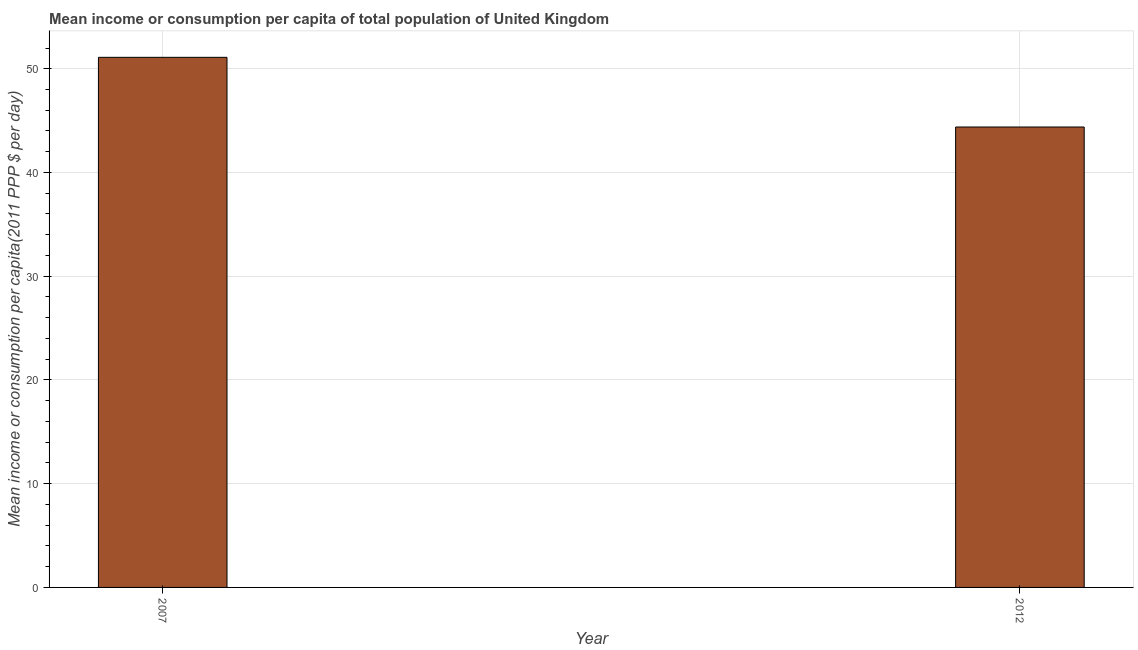Does the graph contain grids?
Provide a short and direct response. Yes. What is the title of the graph?
Offer a very short reply. Mean income or consumption per capita of total population of United Kingdom. What is the label or title of the X-axis?
Provide a short and direct response. Year. What is the label or title of the Y-axis?
Provide a succinct answer. Mean income or consumption per capita(2011 PPP $ per day). What is the mean income or consumption in 2012?
Provide a short and direct response. 44.38. Across all years, what is the maximum mean income or consumption?
Provide a short and direct response. 51.1. Across all years, what is the minimum mean income or consumption?
Provide a succinct answer. 44.38. In which year was the mean income or consumption minimum?
Provide a short and direct response. 2012. What is the sum of the mean income or consumption?
Offer a terse response. 95.49. What is the difference between the mean income or consumption in 2007 and 2012?
Your answer should be compact. 6.72. What is the average mean income or consumption per year?
Offer a very short reply. 47.74. What is the median mean income or consumption?
Provide a succinct answer. 47.74. What is the ratio of the mean income or consumption in 2007 to that in 2012?
Your answer should be very brief. 1.15. In how many years, is the mean income or consumption greater than the average mean income or consumption taken over all years?
Your answer should be compact. 1. Are all the bars in the graph horizontal?
Offer a terse response. No. How many years are there in the graph?
Offer a very short reply. 2. What is the difference between two consecutive major ticks on the Y-axis?
Your response must be concise. 10. Are the values on the major ticks of Y-axis written in scientific E-notation?
Your response must be concise. No. What is the Mean income or consumption per capita(2011 PPP $ per day) in 2007?
Your response must be concise. 51.1. What is the Mean income or consumption per capita(2011 PPP $ per day) of 2012?
Ensure brevity in your answer.  44.38. What is the difference between the Mean income or consumption per capita(2011 PPP $ per day) in 2007 and 2012?
Keep it short and to the point. 6.72. What is the ratio of the Mean income or consumption per capita(2011 PPP $ per day) in 2007 to that in 2012?
Offer a terse response. 1.15. 